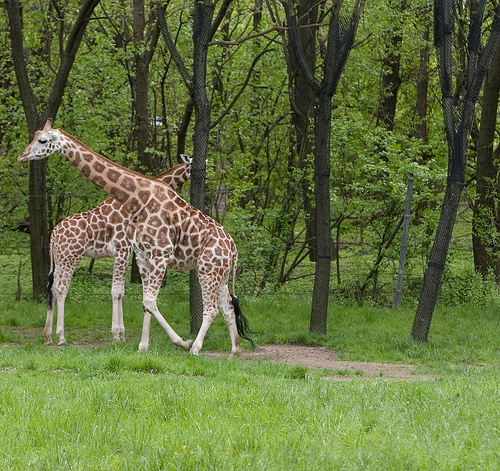Describe the objects in this image and their specific colors. I can see giraffe in olive, darkgray, gray, and lightgray tones and giraffe in olive, darkgray, and gray tones in this image. 